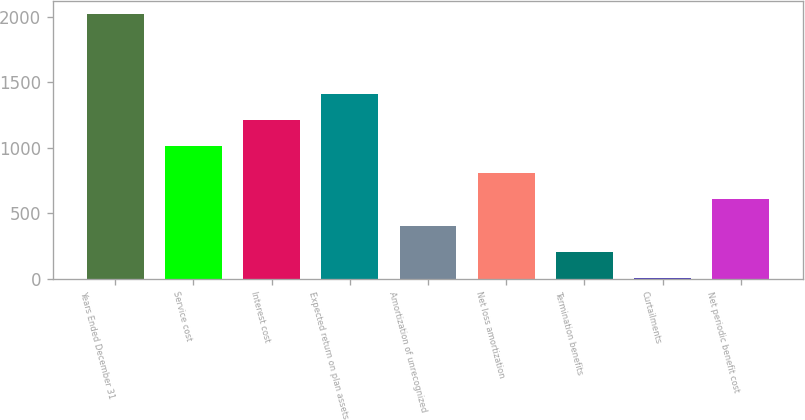<chart> <loc_0><loc_0><loc_500><loc_500><bar_chart><fcel>Years Ended December 31<fcel>Service cost<fcel>Interest cost<fcel>Expected return on plan assets<fcel>Amortization of unrecognized<fcel>Net loss amortization<fcel>Termination benefits<fcel>Curtailments<fcel>Net periodic benefit cost<nl><fcel>2017<fcel>1010<fcel>1211.4<fcel>1412.8<fcel>405.8<fcel>808.6<fcel>204.4<fcel>3<fcel>607.2<nl></chart> 